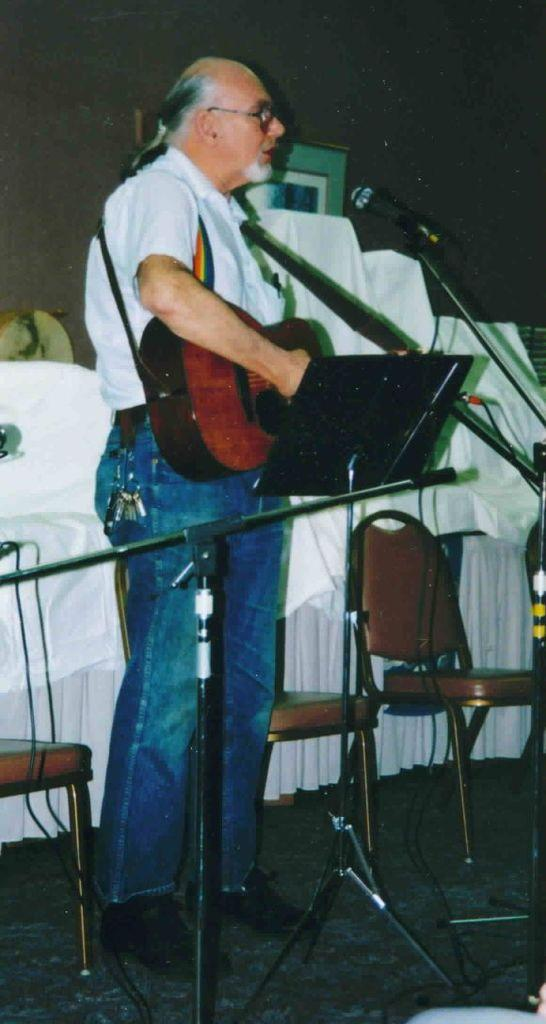What can be seen in the image related to a person? There is a person in the image, and they are wearing glasses (specs). What is the person holding in the image? The person is holding an instrument. What is the person doing with the instrument? The person is playing the instrument. What type of furniture is present in the image? There are chairs in the image. What device is visible for amplifying sound? There is a microphone (mike) in the image. What object is being held by another person in the image? There is a person holding keys in the image. What type of trail can be seen in the image? There is no trail present in the image. What grade of sugar is being used by the person playing the instrument? There is no sugar or indication of sugar use in the image. 